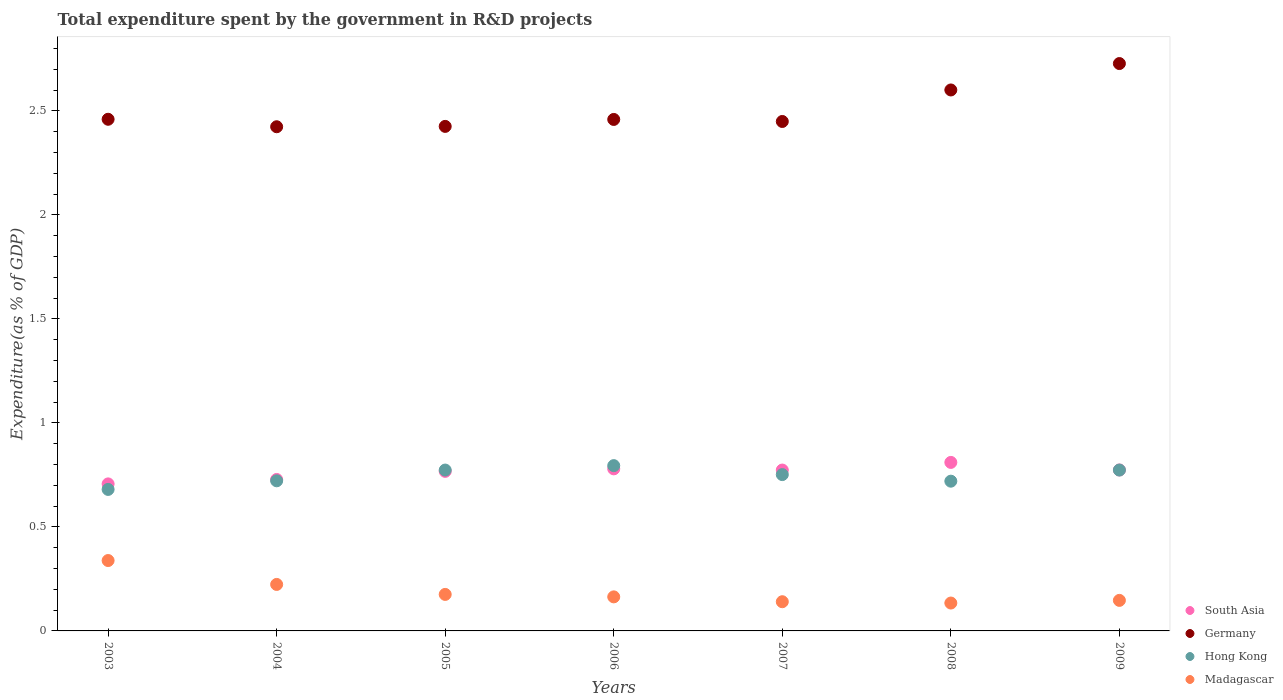How many different coloured dotlines are there?
Offer a terse response. 4. What is the total expenditure spent by the government in R&D projects in Germany in 2005?
Give a very brief answer. 2.43. Across all years, what is the maximum total expenditure spent by the government in R&D projects in Germany?
Give a very brief answer. 2.73. Across all years, what is the minimum total expenditure spent by the government in R&D projects in South Asia?
Offer a very short reply. 0.71. In which year was the total expenditure spent by the government in R&D projects in Germany minimum?
Offer a terse response. 2004. What is the total total expenditure spent by the government in R&D projects in Germany in the graph?
Provide a short and direct response. 17.55. What is the difference between the total expenditure spent by the government in R&D projects in Madagascar in 2004 and that in 2007?
Keep it short and to the point. 0.08. What is the difference between the total expenditure spent by the government in R&D projects in Germany in 2006 and the total expenditure spent by the government in R&D projects in Hong Kong in 2009?
Make the answer very short. 1.69. What is the average total expenditure spent by the government in R&D projects in Madagascar per year?
Keep it short and to the point. 0.19. In the year 2006, what is the difference between the total expenditure spent by the government in R&D projects in South Asia and total expenditure spent by the government in R&D projects in Hong Kong?
Offer a terse response. -0.02. What is the ratio of the total expenditure spent by the government in R&D projects in Germany in 2004 to that in 2005?
Your response must be concise. 1. Is the total expenditure spent by the government in R&D projects in South Asia in 2006 less than that in 2008?
Give a very brief answer. Yes. Is the difference between the total expenditure spent by the government in R&D projects in South Asia in 2004 and 2007 greater than the difference between the total expenditure spent by the government in R&D projects in Hong Kong in 2004 and 2007?
Offer a very short reply. No. What is the difference between the highest and the second highest total expenditure spent by the government in R&D projects in Madagascar?
Give a very brief answer. 0.11. What is the difference between the highest and the lowest total expenditure spent by the government in R&D projects in Hong Kong?
Offer a terse response. 0.11. In how many years, is the total expenditure spent by the government in R&D projects in Germany greater than the average total expenditure spent by the government in R&D projects in Germany taken over all years?
Your response must be concise. 2. Is the sum of the total expenditure spent by the government in R&D projects in Hong Kong in 2004 and 2008 greater than the maximum total expenditure spent by the government in R&D projects in South Asia across all years?
Offer a very short reply. Yes. Is it the case that in every year, the sum of the total expenditure spent by the government in R&D projects in Madagascar and total expenditure spent by the government in R&D projects in Hong Kong  is greater than the sum of total expenditure spent by the government in R&D projects in South Asia and total expenditure spent by the government in R&D projects in Germany?
Your answer should be compact. No. Is it the case that in every year, the sum of the total expenditure spent by the government in R&D projects in Hong Kong and total expenditure spent by the government in R&D projects in South Asia  is greater than the total expenditure spent by the government in R&D projects in Madagascar?
Provide a short and direct response. Yes. Is the total expenditure spent by the government in R&D projects in Hong Kong strictly greater than the total expenditure spent by the government in R&D projects in Madagascar over the years?
Provide a succinct answer. Yes. Is the total expenditure spent by the government in R&D projects in South Asia strictly less than the total expenditure spent by the government in R&D projects in Madagascar over the years?
Your answer should be compact. No. Does the graph contain grids?
Your response must be concise. No. Where does the legend appear in the graph?
Provide a short and direct response. Bottom right. How many legend labels are there?
Make the answer very short. 4. How are the legend labels stacked?
Keep it short and to the point. Vertical. What is the title of the graph?
Keep it short and to the point. Total expenditure spent by the government in R&D projects. Does "Sub-Saharan Africa (all income levels)" appear as one of the legend labels in the graph?
Give a very brief answer. No. What is the label or title of the Y-axis?
Offer a very short reply. Expenditure(as % of GDP). What is the Expenditure(as % of GDP) in South Asia in 2003?
Offer a very short reply. 0.71. What is the Expenditure(as % of GDP) of Germany in 2003?
Offer a very short reply. 2.46. What is the Expenditure(as % of GDP) of Hong Kong in 2003?
Your response must be concise. 0.68. What is the Expenditure(as % of GDP) of Madagascar in 2003?
Offer a terse response. 0.34. What is the Expenditure(as % of GDP) in South Asia in 2004?
Provide a short and direct response. 0.73. What is the Expenditure(as % of GDP) of Germany in 2004?
Your answer should be very brief. 2.42. What is the Expenditure(as % of GDP) of Hong Kong in 2004?
Your answer should be very brief. 0.72. What is the Expenditure(as % of GDP) of Madagascar in 2004?
Offer a very short reply. 0.22. What is the Expenditure(as % of GDP) of South Asia in 2005?
Your answer should be very brief. 0.77. What is the Expenditure(as % of GDP) of Germany in 2005?
Ensure brevity in your answer.  2.43. What is the Expenditure(as % of GDP) of Hong Kong in 2005?
Keep it short and to the point. 0.77. What is the Expenditure(as % of GDP) in Madagascar in 2005?
Offer a very short reply. 0.18. What is the Expenditure(as % of GDP) of South Asia in 2006?
Keep it short and to the point. 0.78. What is the Expenditure(as % of GDP) of Germany in 2006?
Your answer should be very brief. 2.46. What is the Expenditure(as % of GDP) of Hong Kong in 2006?
Give a very brief answer. 0.79. What is the Expenditure(as % of GDP) in Madagascar in 2006?
Keep it short and to the point. 0.16. What is the Expenditure(as % of GDP) in South Asia in 2007?
Your answer should be compact. 0.77. What is the Expenditure(as % of GDP) in Germany in 2007?
Make the answer very short. 2.45. What is the Expenditure(as % of GDP) of Hong Kong in 2007?
Keep it short and to the point. 0.75. What is the Expenditure(as % of GDP) of Madagascar in 2007?
Offer a very short reply. 0.14. What is the Expenditure(as % of GDP) of South Asia in 2008?
Your response must be concise. 0.81. What is the Expenditure(as % of GDP) in Germany in 2008?
Your answer should be very brief. 2.6. What is the Expenditure(as % of GDP) in Hong Kong in 2008?
Offer a terse response. 0.72. What is the Expenditure(as % of GDP) in Madagascar in 2008?
Ensure brevity in your answer.  0.13. What is the Expenditure(as % of GDP) of South Asia in 2009?
Offer a terse response. 0.77. What is the Expenditure(as % of GDP) of Germany in 2009?
Make the answer very short. 2.73. What is the Expenditure(as % of GDP) in Hong Kong in 2009?
Your response must be concise. 0.77. What is the Expenditure(as % of GDP) of Madagascar in 2009?
Your response must be concise. 0.15. Across all years, what is the maximum Expenditure(as % of GDP) of South Asia?
Your answer should be compact. 0.81. Across all years, what is the maximum Expenditure(as % of GDP) in Germany?
Keep it short and to the point. 2.73. Across all years, what is the maximum Expenditure(as % of GDP) of Hong Kong?
Your answer should be very brief. 0.79. Across all years, what is the maximum Expenditure(as % of GDP) of Madagascar?
Provide a succinct answer. 0.34. Across all years, what is the minimum Expenditure(as % of GDP) of South Asia?
Keep it short and to the point. 0.71. Across all years, what is the minimum Expenditure(as % of GDP) in Germany?
Give a very brief answer. 2.42. Across all years, what is the minimum Expenditure(as % of GDP) in Hong Kong?
Your answer should be very brief. 0.68. Across all years, what is the minimum Expenditure(as % of GDP) in Madagascar?
Keep it short and to the point. 0.13. What is the total Expenditure(as % of GDP) in South Asia in the graph?
Provide a succinct answer. 5.34. What is the total Expenditure(as % of GDP) of Germany in the graph?
Your answer should be very brief. 17.55. What is the total Expenditure(as % of GDP) of Hong Kong in the graph?
Offer a very short reply. 5.22. What is the total Expenditure(as % of GDP) of Madagascar in the graph?
Offer a terse response. 1.32. What is the difference between the Expenditure(as % of GDP) in South Asia in 2003 and that in 2004?
Keep it short and to the point. -0.02. What is the difference between the Expenditure(as % of GDP) of Germany in 2003 and that in 2004?
Offer a very short reply. 0.04. What is the difference between the Expenditure(as % of GDP) in Hong Kong in 2003 and that in 2004?
Provide a succinct answer. -0.04. What is the difference between the Expenditure(as % of GDP) in Madagascar in 2003 and that in 2004?
Give a very brief answer. 0.11. What is the difference between the Expenditure(as % of GDP) of South Asia in 2003 and that in 2005?
Offer a terse response. -0.06. What is the difference between the Expenditure(as % of GDP) in Germany in 2003 and that in 2005?
Your answer should be compact. 0.03. What is the difference between the Expenditure(as % of GDP) of Hong Kong in 2003 and that in 2005?
Ensure brevity in your answer.  -0.09. What is the difference between the Expenditure(as % of GDP) in Madagascar in 2003 and that in 2005?
Provide a short and direct response. 0.16. What is the difference between the Expenditure(as % of GDP) of South Asia in 2003 and that in 2006?
Your answer should be compact. -0.07. What is the difference between the Expenditure(as % of GDP) of Germany in 2003 and that in 2006?
Offer a very short reply. 0. What is the difference between the Expenditure(as % of GDP) of Hong Kong in 2003 and that in 2006?
Provide a succinct answer. -0.11. What is the difference between the Expenditure(as % of GDP) in Madagascar in 2003 and that in 2006?
Provide a short and direct response. 0.17. What is the difference between the Expenditure(as % of GDP) in South Asia in 2003 and that in 2007?
Offer a very short reply. -0.07. What is the difference between the Expenditure(as % of GDP) of Germany in 2003 and that in 2007?
Your answer should be compact. 0.01. What is the difference between the Expenditure(as % of GDP) of Hong Kong in 2003 and that in 2007?
Keep it short and to the point. -0.07. What is the difference between the Expenditure(as % of GDP) of Madagascar in 2003 and that in 2007?
Provide a succinct answer. 0.2. What is the difference between the Expenditure(as % of GDP) in South Asia in 2003 and that in 2008?
Ensure brevity in your answer.  -0.1. What is the difference between the Expenditure(as % of GDP) of Germany in 2003 and that in 2008?
Provide a succinct answer. -0.14. What is the difference between the Expenditure(as % of GDP) in Hong Kong in 2003 and that in 2008?
Provide a succinct answer. -0.04. What is the difference between the Expenditure(as % of GDP) in Madagascar in 2003 and that in 2008?
Your response must be concise. 0.2. What is the difference between the Expenditure(as % of GDP) of South Asia in 2003 and that in 2009?
Your answer should be very brief. -0.07. What is the difference between the Expenditure(as % of GDP) in Germany in 2003 and that in 2009?
Provide a succinct answer. -0.27. What is the difference between the Expenditure(as % of GDP) of Hong Kong in 2003 and that in 2009?
Keep it short and to the point. -0.09. What is the difference between the Expenditure(as % of GDP) of Madagascar in 2003 and that in 2009?
Give a very brief answer. 0.19. What is the difference between the Expenditure(as % of GDP) of South Asia in 2004 and that in 2005?
Provide a succinct answer. -0.04. What is the difference between the Expenditure(as % of GDP) in Germany in 2004 and that in 2005?
Give a very brief answer. -0. What is the difference between the Expenditure(as % of GDP) of Hong Kong in 2004 and that in 2005?
Ensure brevity in your answer.  -0.05. What is the difference between the Expenditure(as % of GDP) in Madagascar in 2004 and that in 2005?
Provide a succinct answer. 0.05. What is the difference between the Expenditure(as % of GDP) of South Asia in 2004 and that in 2006?
Your answer should be very brief. -0.05. What is the difference between the Expenditure(as % of GDP) in Germany in 2004 and that in 2006?
Your answer should be very brief. -0.04. What is the difference between the Expenditure(as % of GDP) of Hong Kong in 2004 and that in 2006?
Offer a terse response. -0.07. What is the difference between the Expenditure(as % of GDP) of Madagascar in 2004 and that in 2006?
Offer a very short reply. 0.06. What is the difference between the Expenditure(as % of GDP) in South Asia in 2004 and that in 2007?
Give a very brief answer. -0.05. What is the difference between the Expenditure(as % of GDP) in Germany in 2004 and that in 2007?
Offer a terse response. -0.03. What is the difference between the Expenditure(as % of GDP) of Hong Kong in 2004 and that in 2007?
Provide a succinct answer. -0.03. What is the difference between the Expenditure(as % of GDP) of Madagascar in 2004 and that in 2007?
Your response must be concise. 0.08. What is the difference between the Expenditure(as % of GDP) in South Asia in 2004 and that in 2008?
Your answer should be compact. -0.08. What is the difference between the Expenditure(as % of GDP) in Germany in 2004 and that in 2008?
Offer a terse response. -0.18. What is the difference between the Expenditure(as % of GDP) of Hong Kong in 2004 and that in 2008?
Provide a succinct answer. 0. What is the difference between the Expenditure(as % of GDP) of Madagascar in 2004 and that in 2008?
Ensure brevity in your answer.  0.09. What is the difference between the Expenditure(as % of GDP) in South Asia in 2004 and that in 2009?
Your answer should be compact. -0.05. What is the difference between the Expenditure(as % of GDP) of Germany in 2004 and that in 2009?
Provide a succinct answer. -0.3. What is the difference between the Expenditure(as % of GDP) of Hong Kong in 2004 and that in 2009?
Your response must be concise. -0.05. What is the difference between the Expenditure(as % of GDP) in Madagascar in 2004 and that in 2009?
Keep it short and to the point. 0.08. What is the difference between the Expenditure(as % of GDP) of South Asia in 2005 and that in 2006?
Give a very brief answer. -0.01. What is the difference between the Expenditure(as % of GDP) of Germany in 2005 and that in 2006?
Offer a terse response. -0.03. What is the difference between the Expenditure(as % of GDP) in Hong Kong in 2005 and that in 2006?
Give a very brief answer. -0.02. What is the difference between the Expenditure(as % of GDP) of Madagascar in 2005 and that in 2006?
Provide a short and direct response. 0.01. What is the difference between the Expenditure(as % of GDP) of South Asia in 2005 and that in 2007?
Provide a succinct answer. -0.01. What is the difference between the Expenditure(as % of GDP) in Germany in 2005 and that in 2007?
Provide a short and direct response. -0.02. What is the difference between the Expenditure(as % of GDP) in Hong Kong in 2005 and that in 2007?
Keep it short and to the point. 0.02. What is the difference between the Expenditure(as % of GDP) of Madagascar in 2005 and that in 2007?
Offer a terse response. 0.04. What is the difference between the Expenditure(as % of GDP) in South Asia in 2005 and that in 2008?
Your answer should be compact. -0.04. What is the difference between the Expenditure(as % of GDP) in Germany in 2005 and that in 2008?
Your answer should be very brief. -0.18. What is the difference between the Expenditure(as % of GDP) of Hong Kong in 2005 and that in 2008?
Keep it short and to the point. 0.05. What is the difference between the Expenditure(as % of GDP) of Madagascar in 2005 and that in 2008?
Provide a short and direct response. 0.04. What is the difference between the Expenditure(as % of GDP) of South Asia in 2005 and that in 2009?
Make the answer very short. -0.01. What is the difference between the Expenditure(as % of GDP) of Germany in 2005 and that in 2009?
Provide a short and direct response. -0.3. What is the difference between the Expenditure(as % of GDP) in Hong Kong in 2005 and that in 2009?
Your answer should be compact. 0. What is the difference between the Expenditure(as % of GDP) of Madagascar in 2005 and that in 2009?
Provide a succinct answer. 0.03. What is the difference between the Expenditure(as % of GDP) in South Asia in 2006 and that in 2007?
Give a very brief answer. 0.01. What is the difference between the Expenditure(as % of GDP) in Germany in 2006 and that in 2007?
Ensure brevity in your answer.  0.01. What is the difference between the Expenditure(as % of GDP) in Hong Kong in 2006 and that in 2007?
Give a very brief answer. 0.04. What is the difference between the Expenditure(as % of GDP) in Madagascar in 2006 and that in 2007?
Offer a very short reply. 0.02. What is the difference between the Expenditure(as % of GDP) in South Asia in 2006 and that in 2008?
Give a very brief answer. -0.03. What is the difference between the Expenditure(as % of GDP) in Germany in 2006 and that in 2008?
Your answer should be compact. -0.14. What is the difference between the Expenditure(as % of GDP) in Hong Kong in 2006 and that in 2008?
Your response must be concise. 0.07. What is the difference between the Expenditure(as % of GDP) of Madagascar in 2006 and that in 2008?
Your answer should be very brief. 0.03. What is the difference between the Expenditure(as % of GDP) of South Asia in 2006 and that in 2009?
Your answer should be compact. 0.01. What is the difference between the Expenditure(as % of GDP) of Germany in 2006 and that in 2009?
Keep it short and to the point. -0.27. What is the difference between the Expenditure(as % of GDP) in Hong Kong in 2006 and that in 2009?
Your response must be concise. 0.02. What is the difference between the Expenditure(as % of GDP) of Madagascar in 2006 and that in 2009?
Your response must be concise. 0.02. What is the difference between the Expenditure(as % of GDP) of South Asia in 2007 and that in 2008?
Your response must be concise. -0.04. What is the difference between the Expenditure(as % of GDP) of Germany in 2007 and that in 2008?
Your answer should be compact. -0.15. What is the difference between the Expenditure(as % of GDP) in Hong Kong in 2007 and that in 2008?
Make the answer very short. 0.03. What is the difference between the Expenditure(as % of GDP) of Madagascar in 2007 and that in 2008?
Give a very brief answer. 0.01. What is the difference between the Expenditure(as % of GDP) in South Asia in 2007 and that in 2009?
Ensure brevity in your answer.  -0. What is the difference between the Expenditure(as % of GDP) in Germany in 2007 and that in 2009?
Your response must be concise. -0.28. What is the difference between the Expenditure(as % of GDP) in Hong Kong in 2007 and that in 2009?
Ensure brevity in your answer.  -0.02. What is the difference between the Expenditure(as % of GDP) of Madagascar in 2007 and that in 2009?
Provide a short and direct response. -0.01. What is the difference between the Expenditure(as % of GDP) in South Asia in 2008 and that in 2009?
Offer a terse response. 0.04. What is the difference between the Expenditure(as % of GDP) in Germany in 2008 and that in 2009?
Give a very brief answer. -0.13. What is the difference between the Expenditure(as % of GDP) in Hong Kong in 2008 and that in 2009?
Give a very brief answer. -0.05. What is the difference between the Expenditure(as % of GDP) of Madagascar in 2008 and that in 2009?
Keep it short and to the point. -0.01. What is the difference between the Expenditure(as % of GDP) in South Asia in 2003 and the Expenditure(as % of GDP) in Germany in 2004?
Make the answer very short. -1.72. What is the difference between the Expenditure(as % of GDP) of South Asia in 2003 and the Expenditure(as % of GDP) of Hong Kong in 2004?
Provide a succinct answer. -0.01. What is the difference between the Expenditure(as % of GDP) in South Asia in 2003 and the Expenditure(as % of GDP) in Madagascar in 2004?
Offer a terse response. 0.48. What is the difference between the Expenditure(as % of GDP) of Germany in 2003 and the Expenditure(as % of GDP) of Hong Kong in 2004?
Your answer should be very brief. 1.74. What is the difference between the Expenditure(as % of GDP) in Germany in 2003 and the Expenditure(as % of GDP) in Madagascar in 2004?
Your response must be concise. 2.24. What is the difference between the Expenditure(as % of GDP) in Hong Kong in 2003 and the Expenditure(as % of GDP) in Madagascar in 2004?
Ensure brevity in your answer.  0.46. What is the difference between the Expenditure(as % of GDP) in South Asia in 2003 and the Expenditure(as % of GDP) in Germany in 2005?
Provide a succinct answer. -1.72. What is the difference between the Expenditure(as % of GDP) in South Asia in 2003 and the Expenditure(as % of GDP) in Hong Kong in 2005?
Make the answer very short. -0.07. What is the difference between the Expenditure(as % of GDP) in South Asia in 2003 and the Expenditure(as % of GDP) in Madagascar in 2005?
Make the answer very short. 0.53. What is the difference between the Expenditure(as % of GDP) in Germany in 2003 and the Expenditure(as % of GDP) in Hong Kong in 2005?
Provide a short and direct response. 1.69. What is the difference between the Expenditure(as % of GDP) of Germany in 2003 and the Expenditure(as % of GDP) of Madagascar in 2005?
Ensure brevity in your answer.  2.28. What is the difference between the Expenditure(as % of GDP) in Hong Kong in 2003 and the Expenditure(as % of GDP) in Madagascar in 2005?
Your answer should be compact. 0.5. What is the difference between the Expenditure(as % of GDP) of South Asia in 2003 and the Expenditure(as % of GDP) of Germany in 2006?
Your response must be concise. -1.75. What is the difference between the Expenditure(as % of GDP) in South Asia in 2003 and the Expenditure(as % of GDP) in Hong Kong in 2006?
Make the answer very short. -0.09. What is the difference between the Expenditure(as % of GDP) in South Asia in 2003 and the Expenditure(as % of GDP) in Madagascar in 2006?
Ensure brevity in your answer.  0.54. What is the difference between the Expenditure(as % of GDP) in Germany in 2003 and the Expenditure(as % of GDP) in Hong Kong in 2006?
Provide a short and direct response. 1.67. What is the difference between the Expenditure(as % of GDP) in Germany in 2003 and the Expenditure(as % of GDP) in Madagascar in 2006?
Provide a short and direct response. 2.3. What is the difference between the Expenditure(as % of GDP) in Hong Kong in 2003 and the Expenditure(as % of GDP) in Madagascar in 2006?
Give a very brief answer. 0.52. What is the difference between the Expenditure(as % of GDP) of South Asia in 2003 and the Expenditure(as % of GDP) of Germany in 2007?
Offer a terse response. -1.74. What is the difference between the Expenditure(as % of GDP) in South Asia in 2003 and the Expenditure(as % of GDP) in Hong Kong in 2007?
Offer a very short reply. -0.04. What is the difference between the Expenditure(as % of GDP) in South Asia in 2003 and the Expenditure(as % of GDP) in Madagascar in 2007?
Your answer should be very brief. 0.57. What is the difference between the Expenditure(as % of GDP) of Germany in 2003 and the Expenditure(as % of GDP) of Hong Kong in 2007?
Keep it short and to the point. 1.71. What is the difference between the Expenditure(as % of GDP) in Germany in 2003 and the Expenditure(as % of GDP) in Madagascar in 2007?
Make the answer very short. 2.32. What is the difference between the Expenditure(as % of GDP) of Hong Kong in 2003 and the Expenditure(as % of GDP) of Madagascar in 2007?
Offer a very short reply. 0.54. What is the difference between the Expenditure(as % of GDP) of South Asia in 2003 and the Expenditure(as % of GDP) of Germany in 2008?
Make the answer very short. -1.89. What is the difference between the Expenditure(as % of GDP) of South Asia in 2003 and the Expenditure(as % of GDP) of Hong Kong in 2008?
Make the answer very short. -0.01. What is the difference between the Expenditure(as % of GDP) of South Asia in 2003 and the Expenditure(as % of GDP) of Madagascar in 2008?
Provide a short and direct response. 0.57. What is the difference between the Expenditure(as % of GDP) of Germany in 2003 and the Expenditure(as % of GDP) of Hong Kong in 2008?
Offer a terse response. 1.74. What is the difference between the Expenditure(as % of GDP) of Germany in 2003 and the Expenditure(as % of GDP) of Madagascar in 2008?
Give a very brief answer. 2.33. What is the difference between the Expenditure(as % of GDP) in Hong Kong in 2003 and the Expenditure(as % of GDP) in Madagascar in 2008?
Keep it short and to the point. 0.55. What is the difference between the Expenditure(as % of GDP) in South Asia in 2003 and the Expenditure(as % of GDP) in Germany in 2009?
Keep it short and to the point. -2.02. What is the difference between the Expenditure(as % of GDP) of South Asia in 2003 and the Expenditure(as % of GDP) of Hong Kong in 2009?
Provide a succinct answer. -0.07. What is the difference between the Expenditure(as % of GDP) in South Asia in 2003 and the Expenditure(as % of GDP) in Madagascar in 2009?
Your answer should be very brief. 0.56. What is the difference between the Expenditure(as % of GDP) in Germany in 2003 and the Expenditure(as % of GDP) in Hong Kong in 2009?
Offer a terse response. 1.69. What is the difference between the Expenditure(as % of GDP) in Germany in 2003 and the Expenditure(as % of GDP) in Madagascar in 2009?
Make the answer very short. 2.31. What is the difference between the Expenditure(as % of GDP) in Hong Kong in 2003 and the Expenditure(as % of GDP) in Madagascar in 2009?
Offer a very short reply. 0.53. What is the difference between the Expenditure(as % of GDP) in South Asia in 2004 and the Expenditure(as % of GDP) in Germany in 2005?
Offer a very short reply. -1.7. What is the difference between the Expenditure(as % of GDP) of South Asia in 2004 and the Expenditure(as % of GDP) of Hong Kong in 2005?
Make the answer very short. -0.05. What is the difference between the Expenditure(as % of GDP) of South Asia in 2004 and the Expenditure(as % of GDP) of Madagascar in 2005?
Offer a terse response. 0.55. What is the difference between the Expenditure(as % of GDP) in Germany in 2004 and the Expenditure(as % of GDP) in Hong Kong in 2005?
Your answer should be compact. 1.65. What is the difference between the Expenditure(as % of GDP) in Germany in 2004 and the Expenditure(as % of GDP) in Madagascar in 2005?
Keep it short and to the point. 2.25. What is the difference between the Expenditure(as % of GDP) of Hong Kong in 2004 and the Expenditure(as % of GDP) of Madagascar in 2005?
Provide a short and direct response. 0.55. What is the difference between the Expenditure(as % of GDP) of South Asia in 2004 and the Expenditure(as % of GDP) of Germany in 2006?
Offer a very short reply. -1.73. What is the difference between the Expenditure(as % of GDP) in South Asia in 2004 and the Expenditure(as % of GDP) in Hong Kong in 2006?
Your response must be concise. -0.07. What is the difference between the Expenditure(as % of GDP) of South Asia in 2004 and the Expenditure(as % of GDP) of Madagascar in 2006?
Your response must be concise. 0.56. What is the difference between the Expenditure(as % of GDP) of Germany in 2004 and the Expenditure(as % of GDP) of Hong Kong in 2006?
Give a very brief answer. 1.63. What is the difference between the Expenditure(as % of GDP) in Germany in 2004 and the Expenditure(as % of GDP) in Madagascar in 2006?
Your response must be concise. 2.26. What is the difference between the Expenditure(as % of GDP) of Hong Kong in 2004 and the Expenditure(as % of GDP) of Madagascar in 2006?
Your answer should be very brief. 0.56. What is the difference between the Expenditure(as % of GDP) in South Asia in 2004 and the Expenditure(as % of GDP) in Germany in 2007?
Offer a very short reply. -1.72. What is the difference between the Expenditure(as % of GDP) of South Asia in 2004 and the Expenditure(as % of GDP) of Hong Kong in 2007?
Your answer should be very brief. -0.02. What is the difference between the Expenditure(as % of GDP) of South Asia in 2004 and the Expenditure(as % of GDP) of Madagascar in 2007?
Provide a short and direct response. 0.59. What is the difference between the Expenditure(as % of GDP) of Germany in 2004 and the Expenditure(as % of GDP) of Hong Kong in 2007?
Offer a terse response. 1.67. What is the difference between the Expenditure(as % of GDP) of Germany in 2004 and the Expenditure(as % of GDP) of Madagascar in 2007?
Provide a succinct answer. 2.28. What is the difference between the Expenditure(as % of GDP) of Hong Kong in 2004 and the Expenditure(as % of GDP) of Madagascar in 2007?
Your answer should be compact. 0.58. What is the difference between the Expenditure(as % of GDP) of South Asia in 2004 and the Expenditure(as % of GDP) of Germany in 2008?
Give a very brief answer. -1.87. What is the difference between the Expenditure(as % of GDP) of South Asia in 2004 and the Expenditure(as % of GDP) of Hong Kong in 2008?
Offer a very short reply. 0.01. What is the difference between the Expenditure(as % of GDP) of South Asia in 2004 and the Expenditure(as % of GDP) of Madagascar in 2008?
Provide a short and direct response. 0.59. What is the difference between the Expenditure(as % of GDP) of Germany in 2004 and the Expenditure(as % of GDP) of Hong Kong in 2008?
Provide a succinct answer. 1.7. What is the difference between the Expenditure(as % of GDP) in Germany in 2004 and the Expenditure(as % of GDP) in Madagascar in 2008?
Provide a short and direct response. 2.29. What is the difference between the Expenditure(as % of GDP) in Hong Kong in 2004 and the Expenditure(as % of GDP) in Madagascar in 2008?
Your answer should be compact. 0.59. What is the difference between the Expenditure(as % of GDP) in South Asia in 2004 and the Expenditure(as % of GDP) in Germany in 2009?
Provide a succinct answer. -2. What is the difference between the Expenditure(as % of GDP) of South Asia in 2004 and the Expenditure(as % of GDP) of Hong Kong in 2009?
Your answer should be very brief. -0.05. What is the difference between the Expenditure(as % of GDP) in South Asia in 2004 and the Expenditure(as % of GDP) in Madagascar in 2009?
Offer a terse response. 0.58. What is the difference between the Expenditure(as % of GDP) in Germany in 2004 and the Expenditure(as % of GDP) in Hong Kong in 2009?
Make the answer very short. 1.65. What is the difference between the Expenditure(as % of GDP) of Germany in 2004 and the Expenditure(as % of GDP) of Madagascar in 2009?
Provide a succinct answer. 2.28. What is the difference between the Expenditure(as % of GDP) of Hong Kong in 2004 and the Expenditure(as % of GDP) of Madagascar in 2009?
Your response must be concise. 0.57. What is the difference between the Expenditure(as % of GDP) in South Asia in 2005 and the Expenditure(as % of GDP) in Germany in 2006?
Make the answer very short. -1.69. What is the difference between the Expenditure(as % of GDP) in South Asia in 2005 and the Expenditure(as % of GDP) in Hong Kong in 2006?
Your response must be concise. -0.03. What is the difference between the Expenditure(as % of GDP) in South Asia in 2005 and the Expenditure(as % of GDP) in Madagascar in 2006?
Make the answer very short. 0.6. What is the difference between the Expenditure(as % of GDP) of Germany in 2005 and the Expenditure(as % of GDP) of Hong Kong in 2006?
Provide a short and direct response. 1.63. What is the difference between the Expenditure(as % of GDP) of Germany in 2005 and the Expenditure(as % of GDP) of Madagascar in 2006?
Provide a short and direct response. 2.26. What is the difference between the Expenditure(as % of GDP) in Hong Kong in 2005 and the Expenditure(as % of GDP) in Madagascar in 2006?
Offer a terse response. 0.61. What is the difference between the Expenditure(as % of GDP) in South Asia in 2005 and the Expenditure(as % of GDP) in Germany in 2007?
Provide a succinct answer. -1.68. What is the difference between the Expenditure(as % of GDP) of South Asia in 2005 and the Expenditure(as % of GDP) of Hong Kong in 2007?
Make the answer very short. 0.02. What is the difference between the Expenditure(as % of GDP) of South Asia in 2005 and the Expenditure(as % of GDP) of Madagascar in 2007?
Provide a short and direct response. 0.63. What is the difference between the Expenditure(as % of GDP) in Germany in 2005 and the Expenditure(as % of GDP) in Hong Kong in 2007?
Give a very brief answer. 1.67. What is the difference between the Expenditure(as % of GDP) of Germany in 2005 and the Expenditure(as % of GDP) of Madagascar in 2007?
Provide a short and direct response. 2.29. What is the difference between the Expenditure(as % of GDP) of Hong Kong in 2005 and the Expenditure(as % of GDP) of Madagascar in 2007?
Give a very brief answer. 0.63. What is the difference between the Expenditure(as % of GDP) in South Asia in 2005 and the Expenditure(as % of GDP) in Germany in 2008?
Your answer should be very brief. -1.83. What is the difference between the Expenditure(as % of GDP) in South Asia in 2005 and the Expenditure(as % of GDP) in Hong Kong in 2008?
Your answer should be very brief. 0.05. What is the difference between the Expenditure(as % of GDP) of South Asia in 2005 and the Expenditure(as % of GDP) of Madagascar in 2008?
Your response must be concise. 0.63. What is the difference between the Expenditure(as % of GDP) of Germany in 2005 and the Expenditure(as % of GDP) of Hong Kong in 2008?
Provide a succinct answer. 1.71. What is the difference between the Expenditure(as % of GDP) in Germany in 2005 and the Expenditure(as % of GDP) in Madagascar in 2008?
Your response must be concise. 2.29. What is the difference between the Expenditure(as % of GDP) of Hong Kong in 2005 and the Expenditure(as % of GDP) of Madagascar in 2008?
Provide a succinct answer. 0.64. What is the difference between the Expenditure(as % of GDP) in South Asia in 2005 and the Expenditure(as % of GDP) in Germany in 2009?
Give a very brief answer. -1.96. What is the difference between the Expenditure(as % of GDP) of South Asia in 2005 and the Expenditure(as % of GDP) of Hong Kong in 2009?
Make the answer very short. -0.01. What is the difference between the Expenditure(as % of GDP) in South Asia in 2005 and the Expenditure(as % of GDP) in Madagascar in 2009?
Make the answer very short. 0.62. What is the difference between the Expenditure(as % of GDP) in Germany in 2005 and the Expenditure(as % of GDP) in Hong Kong in 2009?
Provide a succinct answer. 1.65. What is the difference between the Expenditure(as % of GDP) in Germany in 2005 and the Expenditure(as % of GDP) in Madagascar in 2009?
Your response must be concise. 2.28. What is the difference between the Expenditure(as % of GDP) of Hong Kong in 2005 and the Expenditure(as % of GDP) of Madagascar in 2009?
Keep it short and to the point. 0.63. What is the difference between the Expenditure(as % of GDP) of South Asia in 2006 and the Expenditure(as % of GDP) of Germany in 2007?
Make the answer very short. -1.67. What is the difference between the Expenditure(as % of GDP) of South Asia in 2006 and the Expenditure(as % of GDP) of Hong Kong in 2007?
Your answer should be compact. 0.03. What is the difference between the Expenditure(as % of GDP) in South Asia in 2006 and the Expenditure(as % of GDP) in Madagascar in 2007?
Your response must be concise. 0.64. What is the difference between the Expenditure(as % of GDP) of Germany in 2006 and the Expenditure(as % of GDP) of Hong Kong in 2007?
Ensure brevity in your answer.  1.71. What is the difference between the Expenditure(as % of GDP) of Germany in 2006 and the Expenditure(as % of GDP) of Madagascar in 2007?
Your answer should be compact. 2.32. What is the difference between the Expenditure(as % of GDP) in Hong Kong in 2006 and the Expenditure(as % of GDP) in Madagascar in 2007?
Make the answer very short. 0.65. What is the difference between the Expenditure(as % of GDP) in South Asia in 2006 and the Expenditure(as % of GDP) in Germany in 2008?
Keep it short and to the point. -1.82. What is the difference between the Expenditure(as % of GDP) in South Asia in 2006 and the Expenditure(as % of GDP) in Hong Kong in 2008?
Offer a very short reply. 0.06. What is the difference between the Expenditure(as % of GDP) of South Asia in 2006 and the Expenditure(as % of GDP) of Madagascar in 2008?
Your answer should be compact. 0.65. What is the difference between the Expenditure(as % of GDP) in Germany in 2006 and the Expenditure(as % of GDP) in Hong Kong in 2008?
Make the answer very short. 1.74. What is the difference between the Expenditure(as % of GDP) in Germany in 2006 and the Expenditure(as % of GDP) in Madagascar in 2008?
Offer a terse response. 2.33. What is the difference between the Expenditure(as % of GDP) in Hong Kong in 2006 and the Expenditure(as % of GDP) in Madagascar in 2008?
Your response must be concise. 0.66. What is the difference between the Expenditure(as % of GDP) of South Asia in 2006 and the Expenditure(as % of GDP) of Germany in 2009?
Offer a terse response. -1.95. What is the difference between the Expenditure(as % of GDP) of South Asia in 2006 and the Expenditure(as % of GDP) of Hong Kong in 2009?
Offer a terse response. 0.01. What is the difference between the Expenditure(as % of GDP) in South Asia in 2006 and the Expenditure(as % of GDP) in Madagascar in 2009?
Your response must be concise. 0.63. What is the difference between the Expenditure(as % of GDP) of Germany in 2006 and the Expenditure(as % of GDP) of Hong Kong in 2009?
Offer a terse response. 1.69. What is the difference between the Expenditure(as % of GDP) of Germany in 2006 and the Expenditure(as % of GDP) of Madagascar in 2009?
Make the answer very short. 2.31. What is the difference between the Expenditure(as % of GDP) in Hong Kong in 2006 and the Expenditure(as % of GDP) in Madagascar in 2009?
Offer a very short reply. 0.65. What is the difference between the Expenditure(as % of GDP) of South Asia in 2007 and the Expenditure(as % of GDP) of Germany in 2008?
Your answer should be very brief. -1.83. What is the difference between the Expenditure(as % of GDP) of South Asia in 2007 and the Expenditure(as % of GDP) of Hong Kong in 2008?
Your answer should be compact. 0.05. What is the difference between the Expenditure(as % of GDP) in South Asia in 2007 and the Expenditure(as % of GDP) in Madagascar in 2008?
Your response must be concise. 0.64. What is the difference between the Expenditure(as % of GDP) of Germany in 2007 and the Expenditure(as % of GDP) of Hong Kong in 2008?
Your answer should be very brief. 1.73. What is the difference between the Expenditure(as % of GDP) in Germany in 2007 and the Expenditure(as % of GDP) in Madagascar in 2008?
Make the answer very short. 2.32. What is the difference between the Expenditure(as % of GDP) of Hong Kong in 2007 and the Expenditure(as % of GDP) of Madagascar in 2008?
Keep it short and to the point. 0.62. What is the difference between the Expenditure(as % of GDP) in South Asia in 2007 and the Expenditure(as % of GDP) in Germany in 2009?
Your answer should be very brief. -1.95. What is the difference between the Expenditure(as % of GDP) of South Asia in 2007 and the Expenditure(as % of GDP) of Madagascar in 2009?
Offer a very short reply. 0.63. What is the difference between the Expenditure(as % of GDP) in Germany in 2007 and the Expenditure(as % of GDP) in Hong Kong in 2009?
Offer a terse response. 1.68. What is the difference between the Expenditure(as % of GDP) in Germany in 2007 and the Expenditure(as % of GDP) in Madagascar in 2009?
Provide a succinct answer. 2.3. What is the difference between the Expenditure(as % of GDP) in Hong Kong in 2007 and the Expenditure(as % of GDP) in Madagascar in 2009?
Your answer should be compact. 0.6. What is the difference between the Expenditure(as % of GDP) in South Asia in 2008 and the Expenditure(as % of GDP) in Germany in 2009?
Give a very brief answer. -1.92. What is the difference between the Expenditure(as % of GDP) in South Asia in 2008 and the Expenditure(as % of GDP) in Hong Kong in 2009?
Offer a terse response. 0.04. What is the difference between the Expenditure(as % of GDP) in South Asia in 2008 and the Expenditure(as % of GDP) in Madagascar in 2009?
Your answer should be very brief. 0.66. What is the difference between the Expenditure(as % of GDP) of Germany in 2008 and the Expenditure(as % of GDP) of Hong Kong in 2009?
Give a very brief answer. 1.83. What is the difference between the Expenditure(as % of GDP) in Germany in 2008 and the Expenditure(as % of GDP) in Madagascar in 2009?
Your answer should be compact. 2.45. What is the difference between the Expenditure(as % of GDP) in Hong Kong in 2008 and the Expenditure(as % of GDP) in Madagascar in 2009?
Ensure brevity in your answer.  0.57. What is the average Expenditure(as % of GDP) in South Asia per year?
Give a very brief answer. 0.76. What is the average Expenditure(as % of GDP) in Germany per year?
Your answer should be very brief. 2.51. What is the average Expenditure(as % of GDP) in Hong Kong per year?
Give a very brief answer. 0.74. What is the average Expenditure(as % of GDP) in Madagascar per year?
Give a very brief answer. 0.19. In the year 2003, what is the difference between the Expenditure(as % of GDP) in South Asia and Expenditure(as % of GDP) in Germany?
Your response must be concise. -1.75. In the year 2003, what is the difference between the Expenditure(as % of GDP) of South Asia and Expenditure(as % of GDP) of Hong Kong?
Provide a short and direct response. 0.03. In the year 2003, what is the difference between the Expenditure(as % of GDP) in South Asia and Expenditure(as % of GDP) in Madagascar?
Make the answer very short. 0.37. In the year 2003, what is the difference between the Expenditure(as % of GDP) in Germany and Expenditure(as % of GDP) in Hong Kong?
Offer a very short reply. 1.78. In the year 2003, what is the difference between the Expenditure(as % of GDP) in Germany and Expenditure(as % of GDP) in Madagascar?
Your answer should be very brief. 2.12. In the year 2003, what is the difference between the Expenditure(as % of GDP) in Hong Kong and Expenditure(as % of GDP) in Madagascar?
Offer a very short reply. 0.34. In the year 2004, what is the difference between the Expenditure(as % of GDP) in South Asia and Expenditure(as % of GDP) in Germany?
Provide a short and direct response. -1.7. In the year 2004, what is the difference between the Expenditure(as % of GDP) in South Asia and Expenditure(as % of GDP) in Hong Kong?
Ensure brevity in your answer.  0.01. In the year 2004, what is the difference between the Expenditure(as % of GDP) in South Asia and Expenditure(as % of GDP) in Madagascar?
Make the answer very short. 0.5. In the year 2004, what is the difference between the Expenditure(as % of GDP) of Germany and Expenditure(as % of GDP) of Hong Kong?
Your answer should be very brief. 1.7. In the year 2004, what is the difference between the Expenditure(as % of GDP) in Germany and Expenditure(as % of GDP) in Madagascar?
Offer a terse response. 2.2. In the year 2004, what is the difference between the Expenditure(as % of GDP) in Hong Kong and Expenditure(as % of GDP) in Madagascar?
Give a very brief answer. 0.5. In the year 2005, what is the difference between the Expenditure(as % of GDP) of South Asia and Expenditure(as % of GDP) of Germany?
Provide a short and direct response. -1.66. In the year 2005, what is the difference between the Expenditure(as % of GDP) of South Asia and Expenditure(as % of GDP) of Hong Kong?
Provide a short and direct response. -0.01. In the year 2005, what is the difference between the Expenditure(as % of GDP) of South Asia and Expenditure(as % of GDP) of Madagascar?
Give a very brief answer. 0.59. In the year 2005, what is the difference between the Expenditure(as % of GDP) of Germany and Expenditure(as % of GDP) of Hong Kong?
Provide a succinct answer. 1.65. In the year 2005, what is the difference between the Expenditure(as % of GDP) in Germany and Expenditure(as % of GDP) in Madagascar?
Make the answer very short. 2.25. In the year 2005, what is the difference between the Expenditure(as % of GDP) in Hong Kong and Expenditure(as % of GDP) in Madagascar?
Your response must be concise. 0.6. In the year 2006, what is the difference between the Expenditure(as % of GDP) of South Asia and Expenditure(as % of GDP) of Germany?
Your response must be concise. -1.68. In the year 2006, what is the difference between the Expenditure(as % of GDP) in South Asia and Expenditure(as % of GDP) in Hong Kong?
Your answer should be compact. -0.02. In the year 2006, what is the difference between the Expenditure(as % of GDP) of South Asia and Expenditure(as % of GDP) of Madagascar?
Your response must be concise. 0.62. In the year 2006, what is the difference between the Expenditure(as % of GDP) of Germany and Expenditure(as % of GDP) of Hong Kong?
Your response must be concise. 1.66. In the year 2006, what is the difference between the Expenditure(as % of GDP) of Germany and Expenditure(as % of GDP) of Madagascar?
Your answer should be very brief. 2.3. In the year 2006, what is the difference between the Expenditure(as % of GDP) in Hong Kong and Expenditure(as % of GDP) in Madagascar?
Offer a very short reply. 0.63. In the year 2007, what is the difference between the Expenditure(as % of GDP) in South Asia and Expenditure(as % of GDP) in Germany?
Provide a short and direct response. -1.68. In the year 2007, what is the difference between the Expenditure(as % of GDP) in South Asia and Expenditure(as % of GDP) in Hong Kong?
Offer a terse response. 0.02. In the year 2007, what is the difference between the Expenditure(as % of GDP) of South Asia and Expenditure(as % of GDP) of Madagascar?
Ensure brevity in your answer.  0.63. In the year 2007, what is the difference between the Expenditure(as % of GDP) of Germany and Expenditure(as % of GDP) of Hong Kong?
Give a very brief answer. 1.7. In the year 2007, what is the difference between the Expenditure(as % of GDP) of Germany and Expenditure(as % of GDP) of Madagascar?
Provide a short and direct response. 2.31. In the year 2007, what is the difference between the Expenditure(as % of GDP) in Hong Kong and Expenditure(as % of GDP) in Madagascar?
Your response must be concise. 0.61. In the year 2008, what is the difference between the Expenditure(as % of GDP) in South Asia and Expenditure(as % of GDP) in Germany?
Make the answer very short. -1.79. In the year 2008, what is the difference between the Expenditure(as % of GDP) of South Asia and Expenditure(as % of GDP) of Hong Kong?
Offer a terse response. 0.09. In the year 2008, what is the difference between the Expenditure(as % of GDP) in South Asia and Expenditure(as % of GDP) in Madagascar?
Provide a short and direct response. 0.68. In the year 2008, what is the difference between the Expenditure(as % of GDP) of Germany and Expenditure(as % of GDP) of Hong Kong?
Offer a very short reply. 1.88. In the year 2008, what is the difference between the Expenditure(as % of GDP) of Germany and Expenditure(as % of GDP) of Madagascar?
Provide a succinct answer. 2.47. In the year 2008, what is the difference between the Expenditure(as % of GDP) of Hong Kong and Expenditure(as % of GDP) of Madagascar?
Give a very brief answer. 0.59. In the year 2009, what is the difference between the Expenditure(as % of GDP) of South Asia and Expenditure(as % of GDP) of Germany?
Offer a terse response. -1.95. In the year 2009, what is the difference between the Expenditure(as % of GDP) of South Asia and Expenditure(as % of GDP) of Madagascar?
Provide a short and direct response. 0.63. In the year 2009, what is the difference between the Expenditure(as % of GDP) in Germany and Expenditure(as % of GDP) in Hong Kong?
Provide a short and direct response. 1.95. In the year 2009, what is the difference between the Expenditure(as % of GDP) of Germany and Expenditure(as % of GDP) of Madagascar?
Your answer should be compact. 2.58. In the year 2009, what is the difference between the Expenditure(as % of GDP) in Hong Kong and Expenditure(as % of GDP) in Madagascar?
Your answer should be compact. 0.63. What is the ratio of the Expenditure(as % of GDP) in South Asia in 2003 to that in 2004?
Keep it short and to the point. 0.97. What is the ratio of the Expenditure(as % of GDP) in Germany in 2003 to that in 2004?
Provide a short and direct response. 1.01. What is the ratio of the Expenditure(as % of GDP) in Hong Kong in 2003 to that in 2004?
Keep it short and to the point. 0.94. What is the ratio of the Expenditure(as % of GDP) of Madagascar in 2003 to that in 2004?
Give a very brief answer. 1.51. What is the ratio of the Expenditure(as % of GDP) in South Asia in 2003 to that in 2005?
Your response must be concise. 0.92. What is the ratio of the Expenditure(as % of GDP) of Germany in 2003 to that in 2005?
Your response must be concise. 1.01. What is the ratio of the Expenditure(as % of GDP) of Hong Kong in 2003 to that in 2005?
Keep it short and to the point. 0.88. What is the ratio of the Expenditure(as % of GDP) in Madagascar in 2003 to that in 2005?
Provide a short and direct response. 1.93. What is the ratio of the Expenditure(as % of GDP) of South Asia in 2003 to that in 2006?
Ensure brevity in your answer.  0.91. What is the ratio of the Expenditure(as % of GDP) of Germany in 2003 to that in 2006?
Your answer should be compact. 1. What is the ratio of the Expenditure(as % of GDP) of Hong Kong in 2003 to that in 2006?
Offer a very short reply. 0.86. What is the ratio of the Expenditure(as % of GDP) of Madagascar in 2003 to that in 2006?
Your response must be concise. 2.07. What is the ratio of the Expenditure(as % of GDP) of South Asia in 2003 to that in 2007?
Give a very brief answer. 0.91. What is the ratio of the Expenditure(as % of GDP) in Germany in 2003 to that in 2007?
Give a very brief answer. 1. What is the ratio of the Expenditure(as % of GDP) in Hong Kong in 2003 to that in 2007?
Offer a very short reply. 0.91. What is the ratio of the Expenditure(as % of GDP) of Madagascar in 2003 to that in 2007?
Your answer should be compact. 2.41. What is the ratio of the Expenditure(as % of GDP) of South Asia in 2003 to that in 2008?
Keep it short and to the point. 0.87. What is the ratio of the Expenditure(as % of GDP) of Germany in 2003 to that in 2008?
Offer a terse response. 0.95. What is the ratio of the Expenditure(as % of GDP) in Hong Kong in 2003 to that in 2008?
Ensure brevity in your answer.  0.94. What is the ratio of the Expenditure(as % of GDP) in Madagascar in 2003 to that in 2008?
Give a very brief answer. 2.52. What is the ratio of the Expenditure(as % of GDP) of South Asia in 2003 to that in 2009?
Provide a short and direct response. 0.91. What is the ratio of the Expenditure(as % of GDP) of Germany in 2003 to that in 2009?
Provide a succinct answer. 0.9. What is the ratio of the Expenditure(as % of GDP) of Hong Kong in 2003 to that in 2009?
Give a very brief answer. 0.88. What is the ratio of the Expenditure(as % of GDP) in Madagascar in 2003 to that in 2009?
Provide a succinct answer. 2.3. What is the ratio of the Expenditure(as % of GDP) in South Asia in 2004 to that in 2005?
Offer a very short reply. 0.95. What is the ratio of the Expenditure(as % of GDP) in Germany in 2004 to that in 2005?
Keep it short and to the point. 1. What is the ratio of the Expenditure(as % of GDP) of Hong Kong in 2004 to that in 2005?
Your response must be concise. 0.93. What is the ratio of the Expenditure(as % of GDP) in Madagascar in 2004 to that in 2005?
Keep it short and to the point. 1.27. What is the ratio of the Expenditure(as % of GDP) of South Asia in 2004 to that in 2006?
Provide a short and direct response. 0.93. What is the ratio of the Expenditure(as % of GDP) of Germany in 2004 to that in 2006?
Provide a succinct answer. 0.99. What is the ratio of the Expenditure(as % of GDP) of Hong Kong in 2004 to that in 2006?
Make the answer very short. 0.91. What is the ratio of the Expenditure(as % of GDP) in Madagascar in 2004 to that in 2006?
Your answer should be compact. 1.37. What is the ratio of the Expenditure(as % of GDP) in South Asia in 2004 to that in 2007?
Offer a very short reply. 0.94. What is the ratio of the Expenditure(as % of GDP) in Hong Kong in 2004 to that in 2007?
Provide a short and direct response. 0.96. What is the ratio of the Expenditure(as % of GDP) in Madagascar in 2004 to that in 2007?
Your answer should be very brief. 1.59. What is the ratio of the Expenditure(as % of GDP) in South Asia in 2004 to that in 2008?
Provide a succinct answer. 0.9. What is the ratio of the Expenditure(as % of GDP) in Germany in 2004 to that in 2008?
Your answer should be very brief. 0.93. What is the ratio of the Expenditure(as % of GDP) of Madagascar in 2004 to that in 2008?
Ensure brevity in your answer.  1.67. What is the ratio of the Expenditure(as % of GDP) of South Asia in 2004 to that in 2009?
Your answer should be compact. 0.94. What is the ratio of the Expenditure(as % of GDP) in Germany in 2004 to that in 2009?
Offer a terse response. 0.89. What is the ratio of the Expenditure(as % of GDP) in Hong Kong in 2004 to that in 2009?
Your answer should be compact. 0.93. What is the ratio of the Expenditure(as % of GDP) in Madagascar in 2004 to that in 2009?
Ensure brevity in your answer.  1.52. What is the ratio of the Expenditure(as % of GDP) of South Asia in 2005 to that in 2006?
Your answer should be very brief. 0.98. What is the ratio of the Expenditure(as % of GDP) in Germany in 2005 to that in 2006?
Give a very brief answer. 0.99. What is the ratio of the Expenditure(as % of GDP) of Hong Kong in 2005 to that in 2006?
Your response must be concise. 0.97. What is the ratio of the Expenditure(as % of GDP) in Madagascar in 2005 to that in 2006?
Your answer should be very brief. 1.07. What is the ratio of the Expenditure(as % of GDP) of South Asia in 2005 to that in 2007?
Your answer should be very brief. 0.99. What is the ratio of the Expenditure(as % of GDP) of Hong Kong in 2005 to that in 2007?
Make the answer very short. 1.03. What is the ratio of the Expenditure(as % of GDP) of Madagascar in 2005 to that in 2007?
Offer a very short reply. 1.25. What is the ratio of the Expenditure(as % of GDP) in South Asia in 2005 to that in 2008?
Your response must be concise. 0.95. What is the ratio of the Expenditure(as % of GDP) of Germany in 2005 to that in 2008?
Offer a terse response. 0.93. What is the ratio of the Expenditure(as % of GDP) of Hong Kong in 2005 to that in 2008?
Your answer should be compact. 1.07. What is the ratio of the Expenditure(as % of GDP) in Madagascar in 2005 to that in 2008?
Provide a short and direct response. 1.31. What is the ratio of the Expenditure(as % of GDP) in Germany in 2005 to that in 2009?
Ensure brevity in your answer.  0.89. What is the ratio of the Expenditure(as % of GDP) in Madagascar in 2005 to that in 2009?
Provide a succinct answer. 1.2. What is the ratio of the Expenditure(as % of GDP) of South Asia in 2006 to that in 2007?
Offer a very short reply. 1.01. What is the ratio of the Expenditure(as % of GDP) of Hong Kong in 2006 to that in 2007?
Your response must be concise. 1.06. What is the ratio of the Expenditure(as % of GDP) of Madagascar in 2006 to that in 2007?
Ensure brevity in your answer.  1.17. What is the ratio of the Expenditure(as % of GDP) in South Asia in 2006 to that in 2008?
Keep it short and to the point. 0.96. What is the ratio of the Expenditure(as % of GDP) in Germany in 2006 to that in 2008?
Offer a very short reply. 0.95. What is the ratio of the Expenditure(as % of GDP) of Hong Kong in 2006 to that in 2008?
Give a very brief answer. 1.1. What is the ratio of the Expenditure(as % of GDP) of Madagascar in 2006 to that in 2008?
Make the answer very short. 1.22. What is the ratio of the Expenditure(as % of GDP) in Germany in 2006 to that in 2009?
Offer a very short reply. 0.9. What is the ratio of the Expenditure(as % of GDP) in Hong Kong in 2006 to that in 2009?
Give a very brief answer. 1.03. What is the ratio of the Expenditure(as % of GDP) in Madagascar in 2006 to that in 2009?
Your answer should be very brief. 1.11. What is the ratio of the Expenditure(as % of GDP) in South Asia in 2007 to that in 2008?
Offer a very short reply. 0.95. What is the ratio of the Expenditure(as % of GDP) in Germany in 2007 to that in 2008?
Your response must be concise. 0.94. What is the ratio of the Expenditure(as % of GDP) of Hong Kong in 2007 to that in 2008?
Keep it short and to the point. 1.04. What is the ratio of the Expenditure(as % of GDP) of Madagascar in 2007 to that in 2008?
Your answer should be compact. 1.05. What is the ratio of the Expenditure(as % of GDP) in South Asia in 2007 to that in 2009?
Offer a terse response. 1. What is the ratio of the Expenditure(as % of GDP) in Germany in 2007 to that in 2009?
Ensure brevity in your answer.  0.9. What is the ratio of the Expenditure(as % of GDP) of Hong Kong in 2007 to that in 2009?
Keep it short and to the point. 0.97. What is the ratio of the Expenditure(as % of GDP) of Madagascar in 2007 to that in 2009?
Your answer should be compact. 0.96. What is the ratio of the Expenditure(as % of GDP) in South Asia in 2008 to that in 2009?
Your answer should be very brief. 1.05. What is the ratio of the Expenditure(as % of GDP) of Germany in 2008 to that in 2009?
Your response must be concise. 0.95. What is the ratio of the Expenditure(as % of GDP) in Hong Kong in 2008 to that in 2009?
Ensure brevity in your answer.  0.93. What is the ratio of the Expenditure(as % of GDP) of Madagascar in 2008 to that in 2009?
Ensure brevity in your answer.  0.91. What is the difference between the highest and the second highest Expenditure(as % of GDP) in South Asia?
Your response must be concise. 0.03. What is the difference between the highest and the second highest Expenditure(as % of GDP) in Germany?
Provide a succinct answer. 0.13. What is the difference between the highest and the second highest Expenditure(as % of GDP) in Hong Kong?
Offer a very short reply. 0.02. What is the difference between the highest and the second highest Expenditure(as % of GDP) in Madagascar?
Make the answer very short. 0.11. What is the difference between the highest and the lowest Expenditure(as % of GDP) in South Asia?
Keep it short and to the point. 0.1. What is the difference between the highest and the lowest Expenditure(as % of GDP) of Germany?
Your response must be concise. 0.3. What is the difference between the highest and the lowest Expenditure(as % of GDP) of Hong Kong?
Provide a short and direct response. 0.11. What is the difference between the highest and the lowest Expenditure(as % of GDP) of Madagascar?
Offer a terse response. 0.2. 